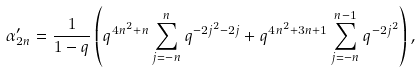<formula> <loc_0><loc_0><loc_500><loc_500>\alpha ^ { \prime } _ { 2 n } = \frac { 1 } { 1 - q } \left ( q ^ { 4 n ^ { 2 } + n } \sum _ { j = - n } ^ { n } q ^ { - 2 j ^ { 2 } - 2 j } + q ^ { 4 n ^ { 2 } + 3 n + 1 } \sum _ { j = - n } ^ { n - 1 } q ^ { - 2 j ^ { 2 } } \right ) ,</formula> 